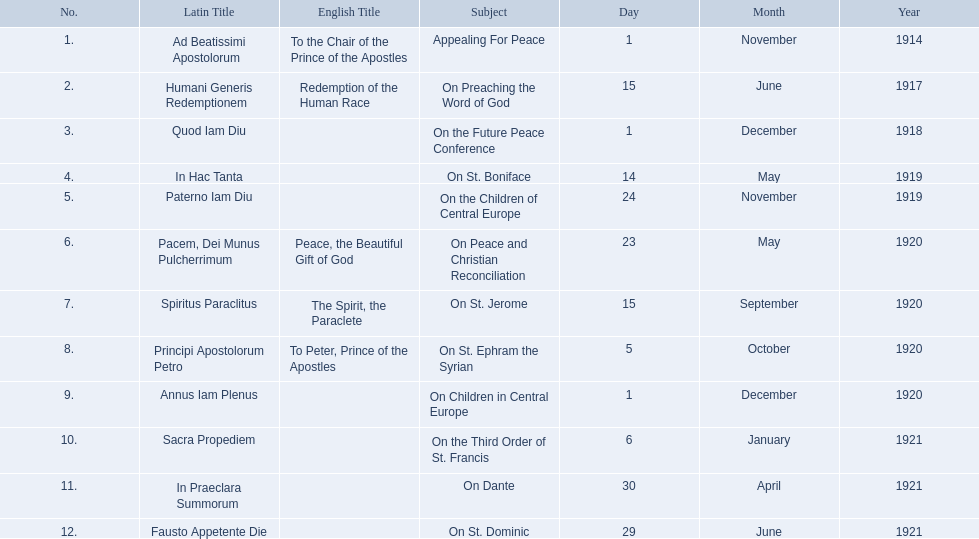What is the dates of the list of encyclicals of pope benedict xv? 1 November 1914, 15 June 1917, 1 December 1918, 14 May 1919, 24 November 1919, 23 May 1920, 15 September 1920, 5 October 1920, 1 December 1920, 6 January 1921, 30 April 1921, 29 June 1921. Of these dates, which subject was on 23 may 1920? On Peace and Christian Reconciliation. 